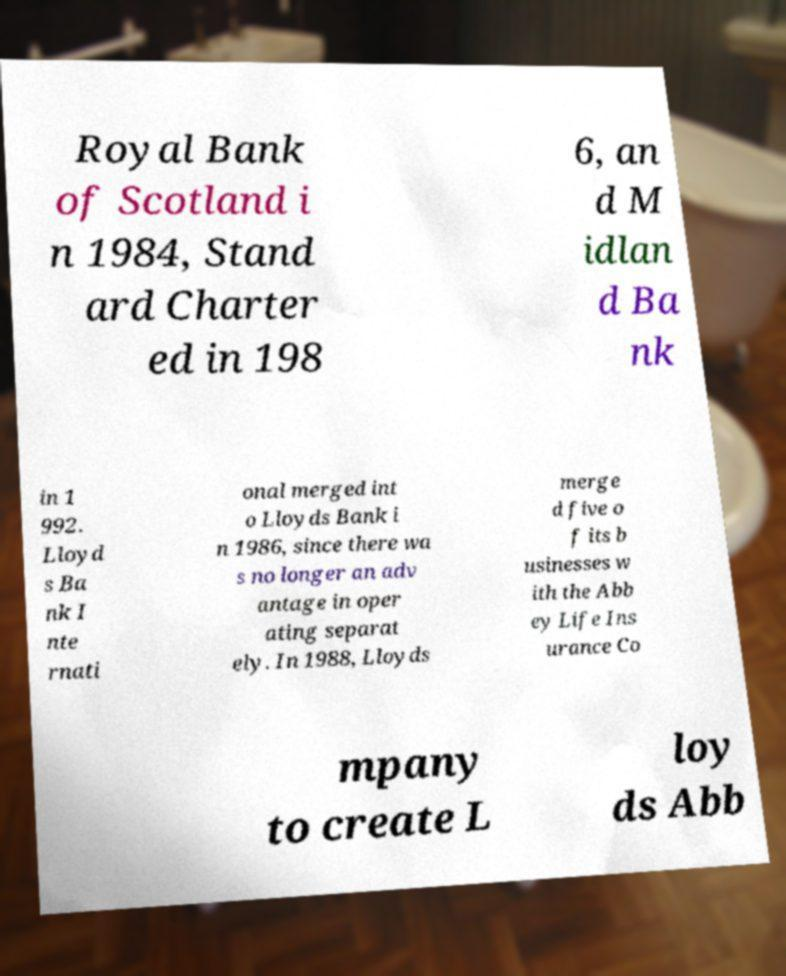Please read and relay the text visible in this image. What does it say? Royal Bank of Scotland i n 1984, Stand ard Charter ed in 198 6, an d M idlan d Ba nk in 1 992. Lloyd s Ba nk I nte rnati onal merged int o Lloyds Bank i n 1986, since there wa s no longer an adv antage in oper ating separat ely. In 1988, Lloyds merge d five o f its b usinesses w ith the Abb ey Life Ins urance Co mpany to create L loy ds Abb 